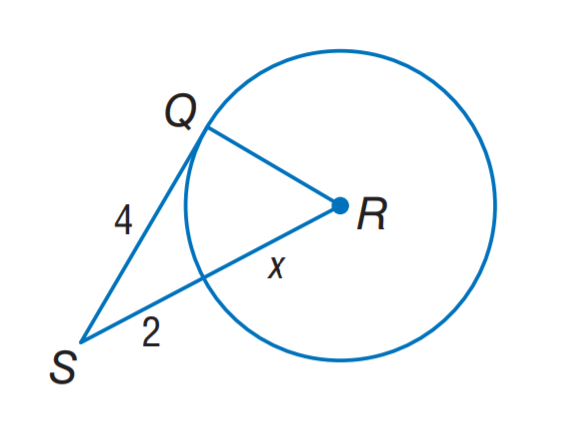Question: Assume that the segment is tangent, find the value of x.
Choices:
A. 2
B. 3
C. 4
D. 5
Answer with the letter. Answer: B 